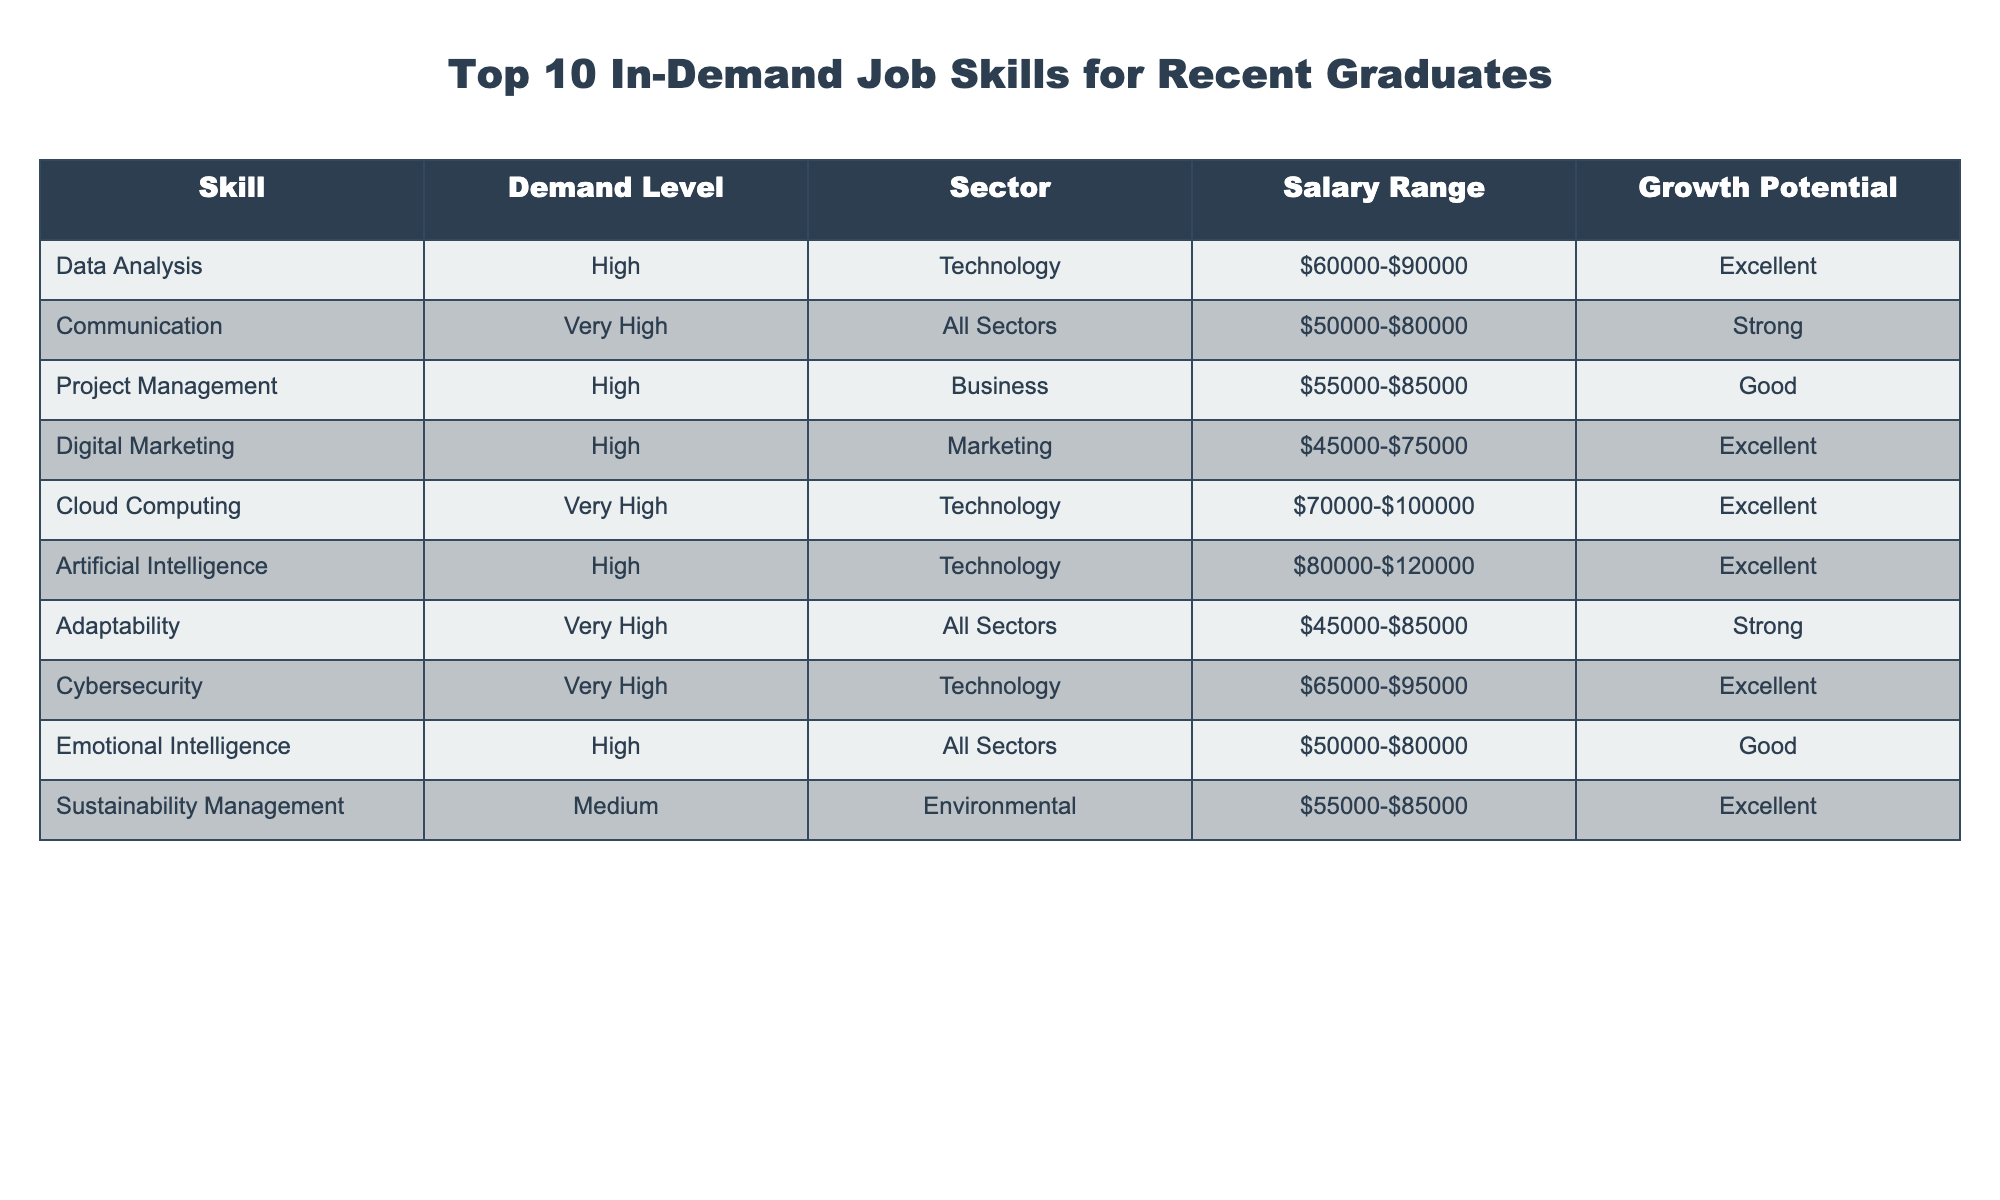What is the highest demand level listed for a skill? The table shows the demand levels for each skill, and "Very High" is the highest demand level indicated.
Answer: Very High Which skill has the highest salary range? Comparing the salary ranges of all skills, "Artificial Intelligence" has the highest salary range listed at $80,000-$120,000.
Answer: Artificial Intelligence How many skills fall under the "Technology" sector? Counting the skills listed under the "Technology" sector, there are four skills: Data Analysis, Cloud Computing, Artificial Intelligence, and Cybersecurity.
Answer: 4 Is "Sustainability Management" considered a high-demand skill? The demand level for "Sustainability Management" is marked as "Medium," which does not qualify it as a high-demand skill.
Answer: No What is the average salary range for the skills with a "High" demand level? The salary ranges for "High" demand skills are: Data Analysis ($60,000-$90,000), Project Management ($55,000-$85,000), Digital Marketing ($45,000-$75,000), Artificial Intelligence ($80,000-$120,000), and Emotional Intelligence ($50,000-$80,000). The averages for these ranges should be calculated individually and then averaged together to find the group average. The midpoint ranges to $75,000, $70,000, $60,000, $100,000, and $65,000 with an average of $68,000.
Answer: $68,000 Which sector has the highest demand level skill? The "Technology" sector has two skills listed with "Very High" demand (Cloud Computing and Cybersecurity) while the "All Sectors" category has one skill ("Communication") with "Very High" demand. Therefore, Technology has the highest.
Answer: Technology Are there any skills listed as having "Good" growth potential? Yes, "Project Management" and "Emotional Intelligence" are both skills listed with "Good" growth potential in the table.
Answer: Yes Which skill with "Very High" demand has the lowest salary range? Among the skills with a "Very High" demand level, "Adaptability" offers the lowest salary range of $45,000-$85,000.
Answer: Adaptability What is the demand level of "Digital Marketing"? The table specifies that "Digital Marketing" has a "High" demand level.
Answer: High If a recent graduate has skills in both "Cloud Computing" and "Communication", what would be their potential salary range? "Cloud Computing" offers a salary range of $70,000-$100,000 and "Communication" offers $50,000-$80,000. Therefore, their potential salary range spans from the minimum of $50,000 to the maximum of $100,000.
Answer: $50,000-$100,000 Which skills are categorized under "All Sectors"? The skills categorized under "All Sectors" are Communication, Adaptability, and Emotional Intelligence.
Answer: Communication, Adaptability, Emotional Intelligence 